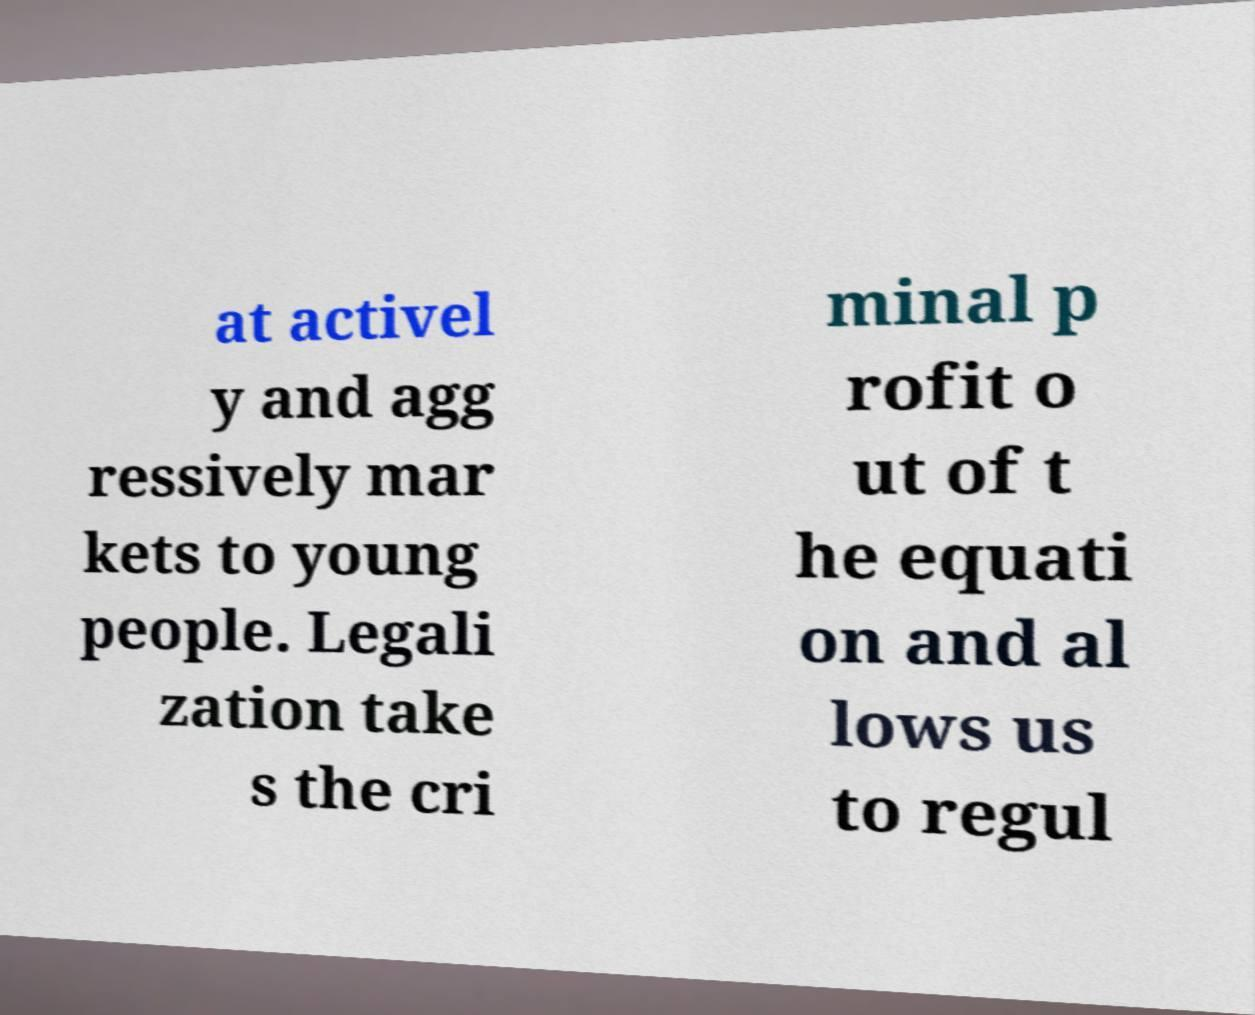I need the written content from this picture converted into text. Can you do that? at activel y and agg ressively mar kets to young people. Legali zation take s the cri minal p rofit o ut of t he equati on and al lows us to regul 